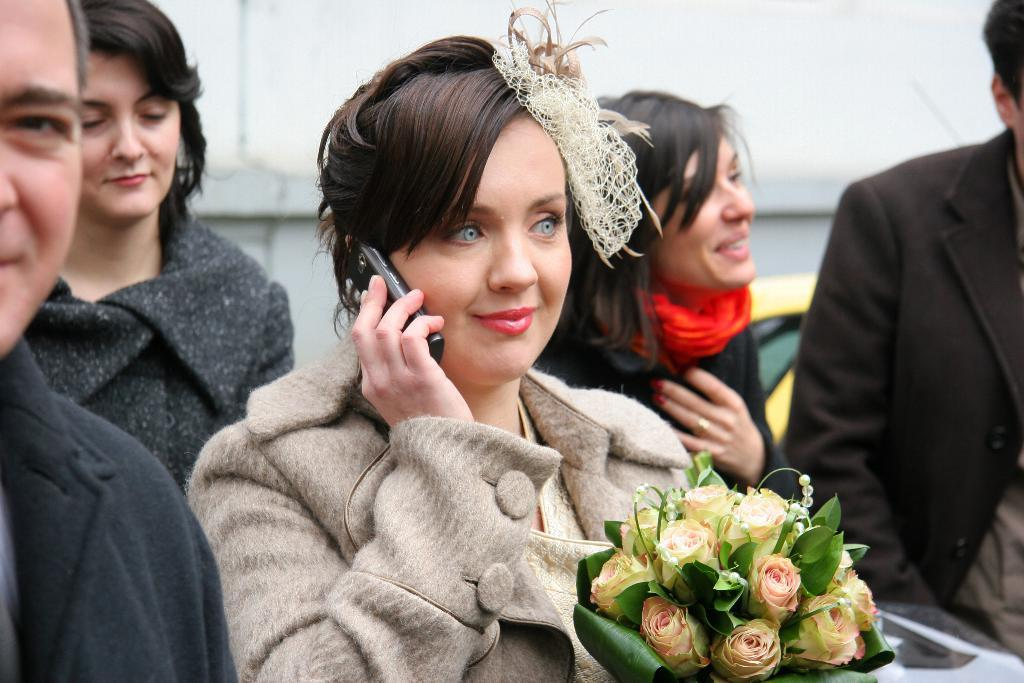How many people are present in the image? There are five persons in the image. What object can be seen in the image besides the people? There is a bouquet in the image. What type of background element is visible in the image? There is a wall in the image. What color is the crayon being used by one of the persons in the image? There is no crayon present in the image, and therefore no such activity can be observed. How much does the scale weigh in the image? There is no scale present in the image, so it cannot be determined how much it weighs. 